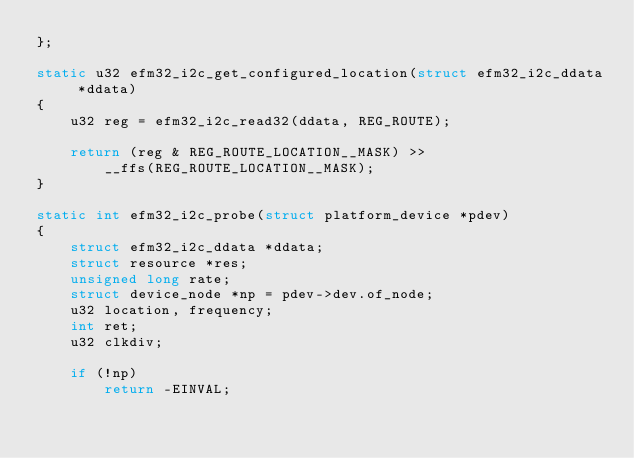<code> <loc_0><loc_0><loc_500><loc_500><_C_>};

static u32 efm32_i2c_get_configured_location(struct efm32_i2c_ddata *ddata)
{
	u32 reg = efm32_i2c_read32(ddata, REG_ROUTE);

	return (reg & REG_ROUTE_LOCATION__MASK) >>
		__ffs(REG_ROUTE_LOCATION__MASK);
}

static int efm32_i2c_probe(struct platform_device *pdev)
{
	struct efm32_i2c_ddata *ddata;
	struct resource *res;
	unsigned long rate;
	struct device_node *np = pdev->dev.of_node;
	u32 location, frequency;
	int ret;
	u32 clkdiv;

	if (!np)
		return -EINVAL;
</code> 